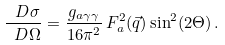Convert formula to latex. <formula><loc_0><loc_0><loc_500><loc_500>\frac { \ D \sigma } { \ D \Omega } = \frac { g _ { a \gamma \gamma } } { 1 6 \pi ^ { 2 } } \, F _ { a } ^ { 2 } ( \vec { q } ) \sin ^ { 2 } ( 2 \Theta ) \, .</formula> 